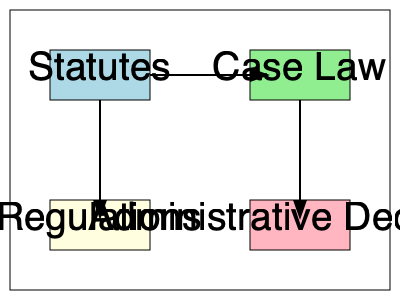Based on the diagram, which type of legal document directly influences both Case Law and Regulations? To answer this question, we need to analyze the relationships shown in the diagram:

1. The diagram displays four types of legal documents: Statutes, Case Law, Regulations, and Administrative Decisions.

2. The arrows in the diagram indicate the flow of influence or derivation between these document types.

3. We can observe that:
   a) There's an arrow from Statutes to Case Law, indicating that Statutes influence Case Law.
   b) There's an arrow from Statutes to Regulations, showing that Statutes also influence Regulations.
   c) Case Law and Administrative Decisions have arrows pointing to them but don't influence other document types in this diagram.

4. The only document type that has arrows originating from it and pointing to both Case Law and Regulations is Statutes.

5. This relationship makes sense in the legal context because:
   a) Statutes (laws passed by legislative bodies) are often interpreted by courts, creating Case Law.
   b) Statutes also authorize and guide the creation of Regulations by executive agencies.

Therefore, based on the relationships shown in the diagram, Statutes is the type of legal document that directly influences both Case Law and Regulations.
Answer: Statutes 